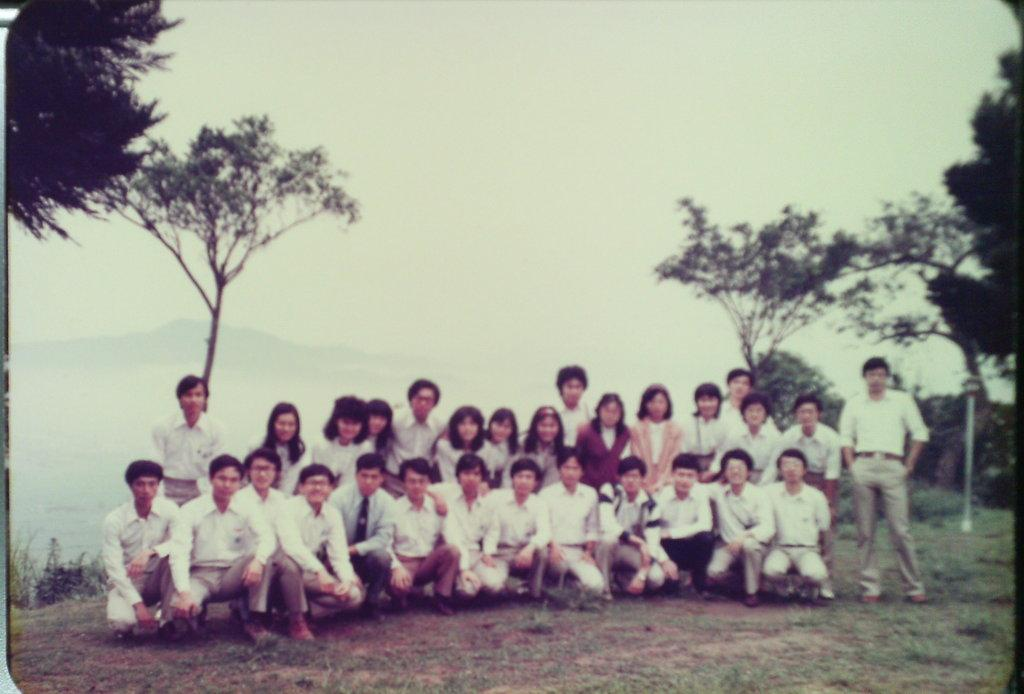What types of people are present in the image? There are boys and girls in the image. Where are the boys and girls located in the image? The boys and girls are sitting in the center of the image. What can be seen in the background of the image? There is greenery visible in the image. What word is being spelled out by the boys and girls in the image? There is no word being spelled out by the boys and girls in the image. Can you see a river in the image? There is no river present in the image. 